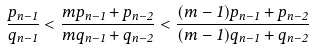<formula> <loc_0><loc_0><loc_500><loc_500>\frac { p _ { n - 1 } } { q _ { n - 1 } } < \frac { m p _ { n - 1 } + p _ { n - 2 } } { m q _ { n - 1 } + q _ { n - 2 } } < \frac { ( m - 1 ) p _ { n - 1 } + p _ { n - 2 } } { ( m - 1 ) q _ { n - 1 } + q _ { n - 2 } }</formula> 